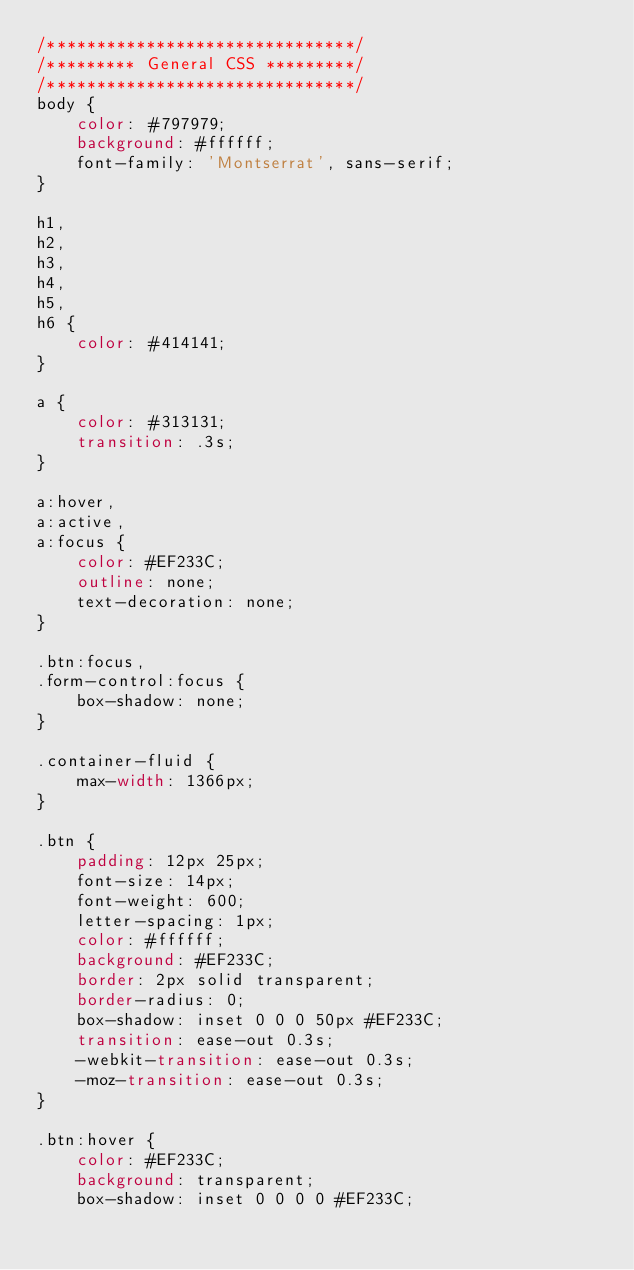<code> <loc_0><loc_0><loc_500><loc_500><_CSS_>/*******************************/
/********* General CSS *********/
/*******************************/
body {
    color: #797979;
    background: #ffffff;
    font-family: 'Montserrat', sans-serif;
}

h1,
h2, 
h3, 
h4,
h5, 
h6 {
    color: #414141;
}

a {
    color: #313131;
    transition: .3s;
}

a:hover,
a:active,
a:focus {
    color: #EF233C;
    outline: none;
    text-decoration: none;
}

.btn:focus,
.form-control:focus {
    box-shadow: none;
}

.container-fluid {
    max-width: 1366px;
}

.btn {
    padding: 12px 25px;
    font-size: 14px;
    font-weight: 600;
    letter-spacing: 1px;
    color: #ffffff;
    background: #EF233C;
    border: 2px solid transparent;
    border-radius: 0;
    box-shadow: inset 0 0 0 50px #EF233C;
    transition: ease-out 0.3s;
    -webkit-transition: ease-out 0.3s;
    -moz-transition: ease-out 0.3s;
}

.btn:hover {
    color: #EF233C;
    background: transparent;
    box-shadow: inset 0 0 0 0 #EF233C;</code> 